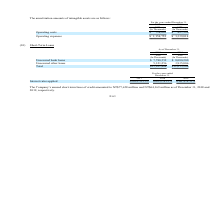According to United Micro Electronics's financial document, What were the company's unsecured bank loans in 2019? According to the financial document, $7,780,552. The relevant text states: "Thousands) (In Thousands) Unsecured bank loans $ 7,780,552 $ 8,080,200 Unsecured other loans 5,323,256 3,935,006 Total $13,103,808 $12,015,206..." Also, How much was Company’s unused short-term lines of credit as of December 31, 2018? According to the financial document, NT$77,658 million. The relevant text states: "y’s unused short-term lines of credit amounted to NT$77,658 million and NT$64,169 million as of December 31, 2018 and 2019, respectively...." Also, How much was Company’s unused short-term lines of credit as of December 31, 2019? According to the financial document, NT$64,169 million. The relevant text states: "lines of credit amounted to NT$77,658 million and NT$64,169 million as of December 31, 2018 and 2019, respectively...." Also, can you calculate: What is the total Unsecured bank loans? Based on the calculation: 7,780,552+8,080,200, the result is 15860752 (in millions). This is based on the information: "Thousands) (In Thousands) Unsecured bank loans $ 7,780,552 $ 8,080,200 Unsecured other loans 5,323,256 3,935,006 Total $13,103,808 $12,015,206 (In Thousands) Unsecured bank loans $ 7,780,552 $ 8,080,2..." The key data points involved are: 7,780,552, 8,080,200. Also, can you calculate: What is the total Unsecured other loans? Based on the calculation: 5,323,256+3,935,006, the result is 9258262 (in millions). This is based on the information: "0,552 $ 8,080,200 Unsecured other loans 5,323,256 3,935,006 Total $13,103,808 $12,015,206 ans $ 7,780,552 $ 8,080,200 Unsecured other loans 5,323,256 3,935,006 Total $13,103,808 $12,015,206..." The key data points involved are: 3,935,006, 5,323,256. Also, can you calculate: What is the average Unsecured other loans? To answer this question, I need to perform calculations using the financial data. The calculation is: (5,323,256+3,935,006) / 2, which equals 4629131 (in millions). This is based on the information: "0,552 $ 8,080,200 Unsecured other loans 5,323,256 3,935,006 Total $13,103,808 $12,015,206 ans $ 7,780,552 $ 8,080,200 Unsecured other loans 5,323,256 3,935,006 Total $13,103,808 $12,015,206..." The key data points involved are: 3,935,006, 5,323,256. 